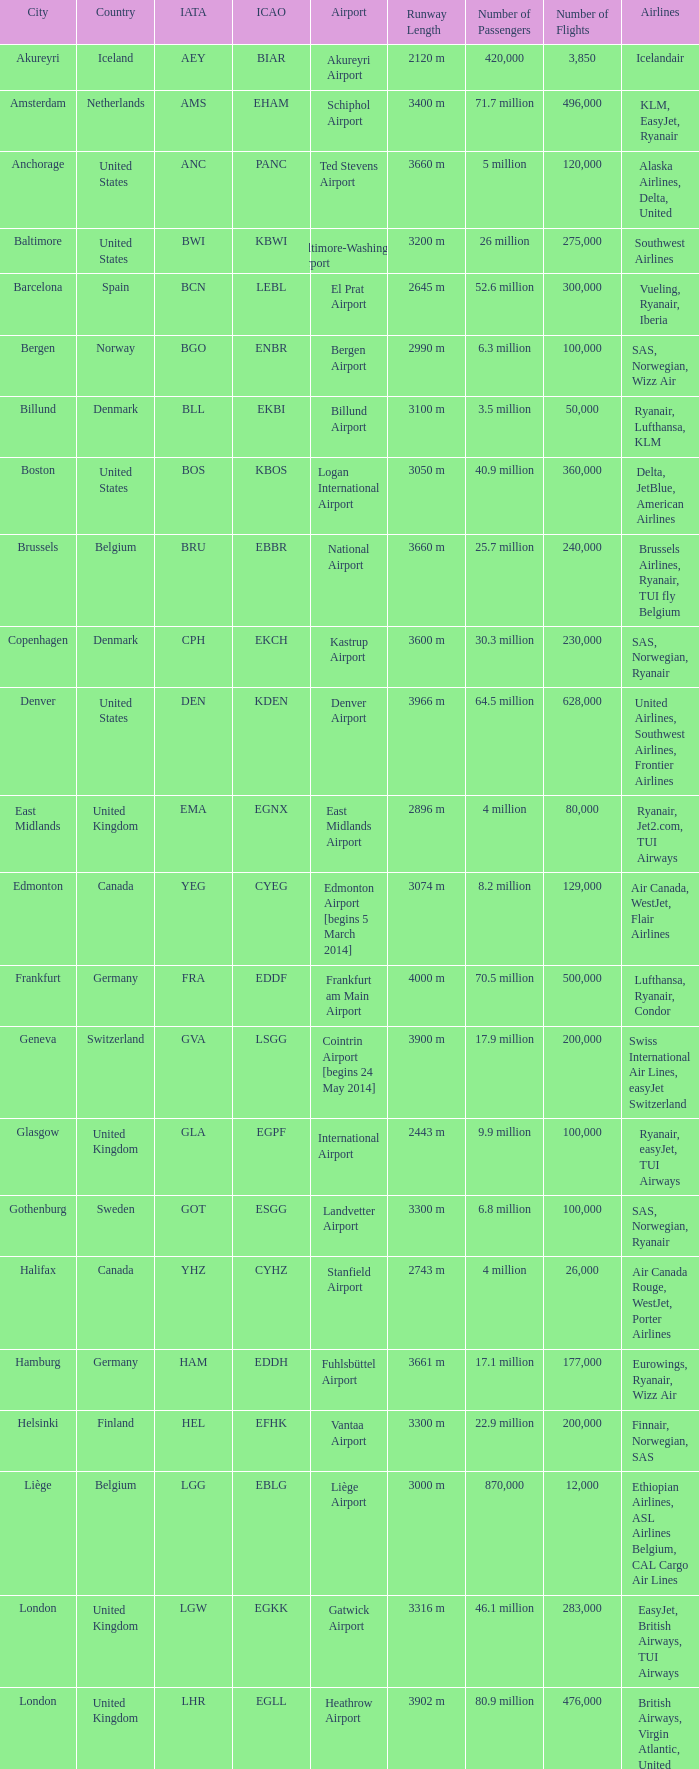What is the IcAO of Frankfurt? EDDF. 